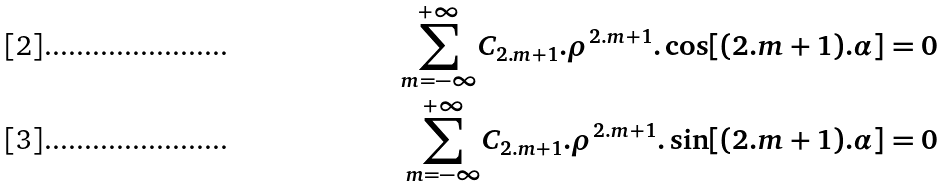<formula> <loc_0><loc_0><loc_500><loc_500>\underset { m = - \infty } { \overset { + \infty } { \sum } } C _ { 2 . m + 1 } . \rho ^ { 2 . m + 1 } . \cos [ ( 2 . m + 1 ) . \alpha ] & = 0 \\ \underset { m = - \infty } { \overset { + \infty } { \sum } } C _ { 2 . m + 1 } . \rho ^ { 2 . m + 1 } . \sin [ ( 2 . m + 1 ) . \alpha ] & = 0</formula> 